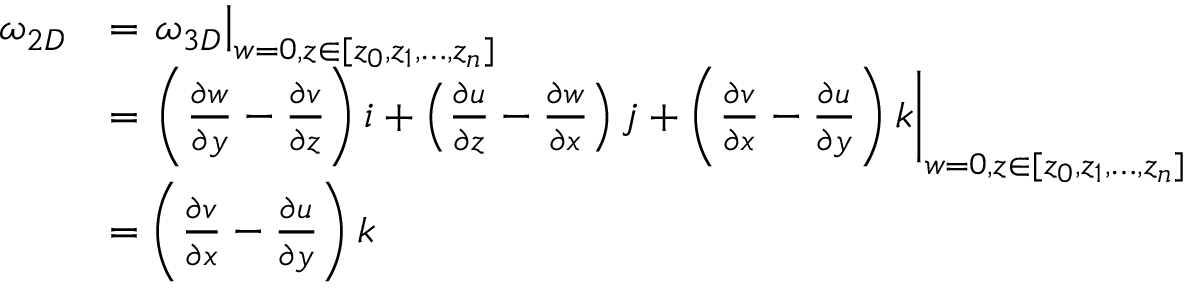Convert formula to latex. <formula><loc_0><loc_0><loc_500><loc_500>\begin{array} { r l } { \omega _ { 2 D } } & { = \omega _ { 3 D } \right | _ { w = 0 , z \in [ z _ { 0 } , z _ { 1 } , \dots , z _ { n } ] } } \\ & { = { \left ( { \frac { \partial w } { \partial y } - \frac { \partial v } { \partial z } } \right ) i + \left ( { \frac { \partial u } { \partial z } - \frac { \partial w } { \partial x } } \right ) j + \left ( { \frac { \partial v } { \partial x } - \frac { \partial u } { \partial y } } \right ) k } \right | _ { w = 0 , z \in [ z _ { 0 } , z _ { 1 } , \dots , z _ { n } ] } } \\ & { = \left ( { \frac { \partial v } { \partial x } - \frac { \partial u } { \partial y } } \right ) k } \end{array}</formula> 